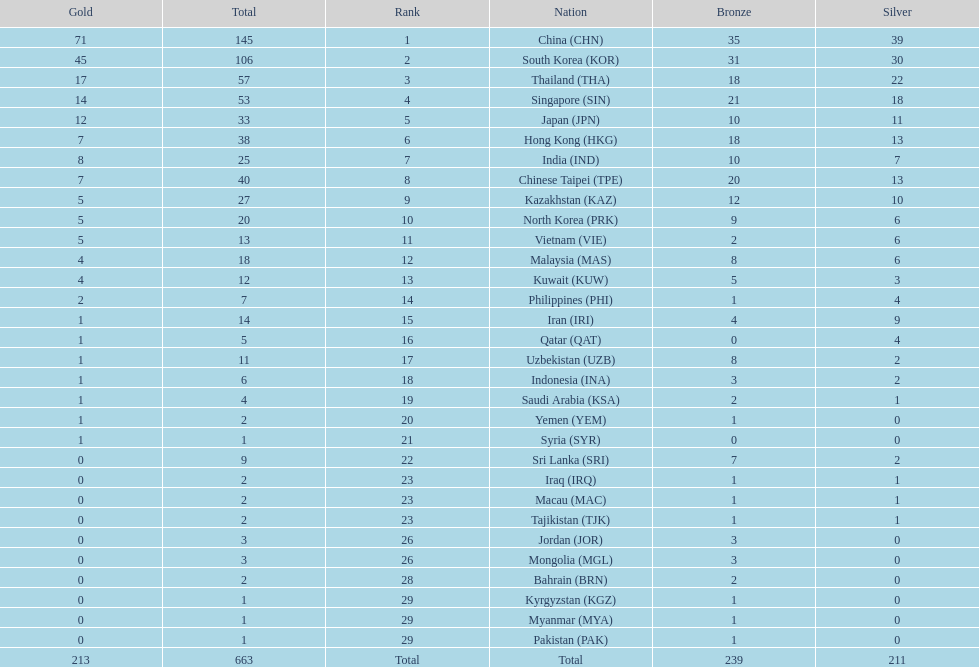How many countries have at least 10 gold medals in the asian youth games? 5. 